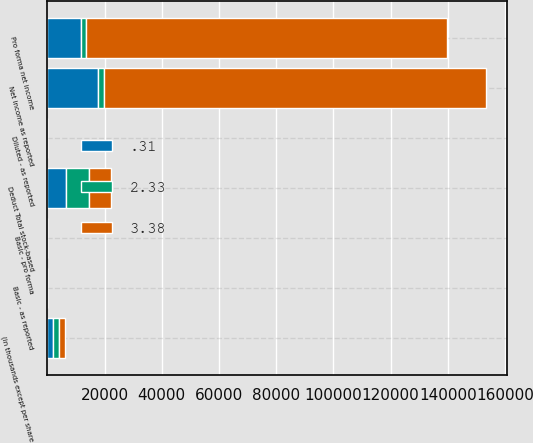Convert chart. <chart><loc_0><loc_0><loc_500><loc_500><stacked_bar_chart><ecel><fcel>(in thousands except per share<fcel>Net income as reported<fcel>Deduct Total stock-based<fcel>Pro forma net income<fcel>Basic - as reported<fcel>Basic - pro forma<fcel>Diluted - as reported<nl><fcel>0.31<fcel>2002<fcel>17652<fcel>6394<fcel>11650<fcel>0.31<fcel>0.2<fcel>0.31<nl><fcel>3.38<fcel>2001<fcel>133575<fcel>7538<fcel>126037<fcel>2.36<fcel>2.23<fcel>2.33<nl><fcel>2.33<fcel>2000<fcel>2000<fcel>8170<fcel>2000<fcel>3.42<fcel>3.28<fcel>3.38<nl></chart> 